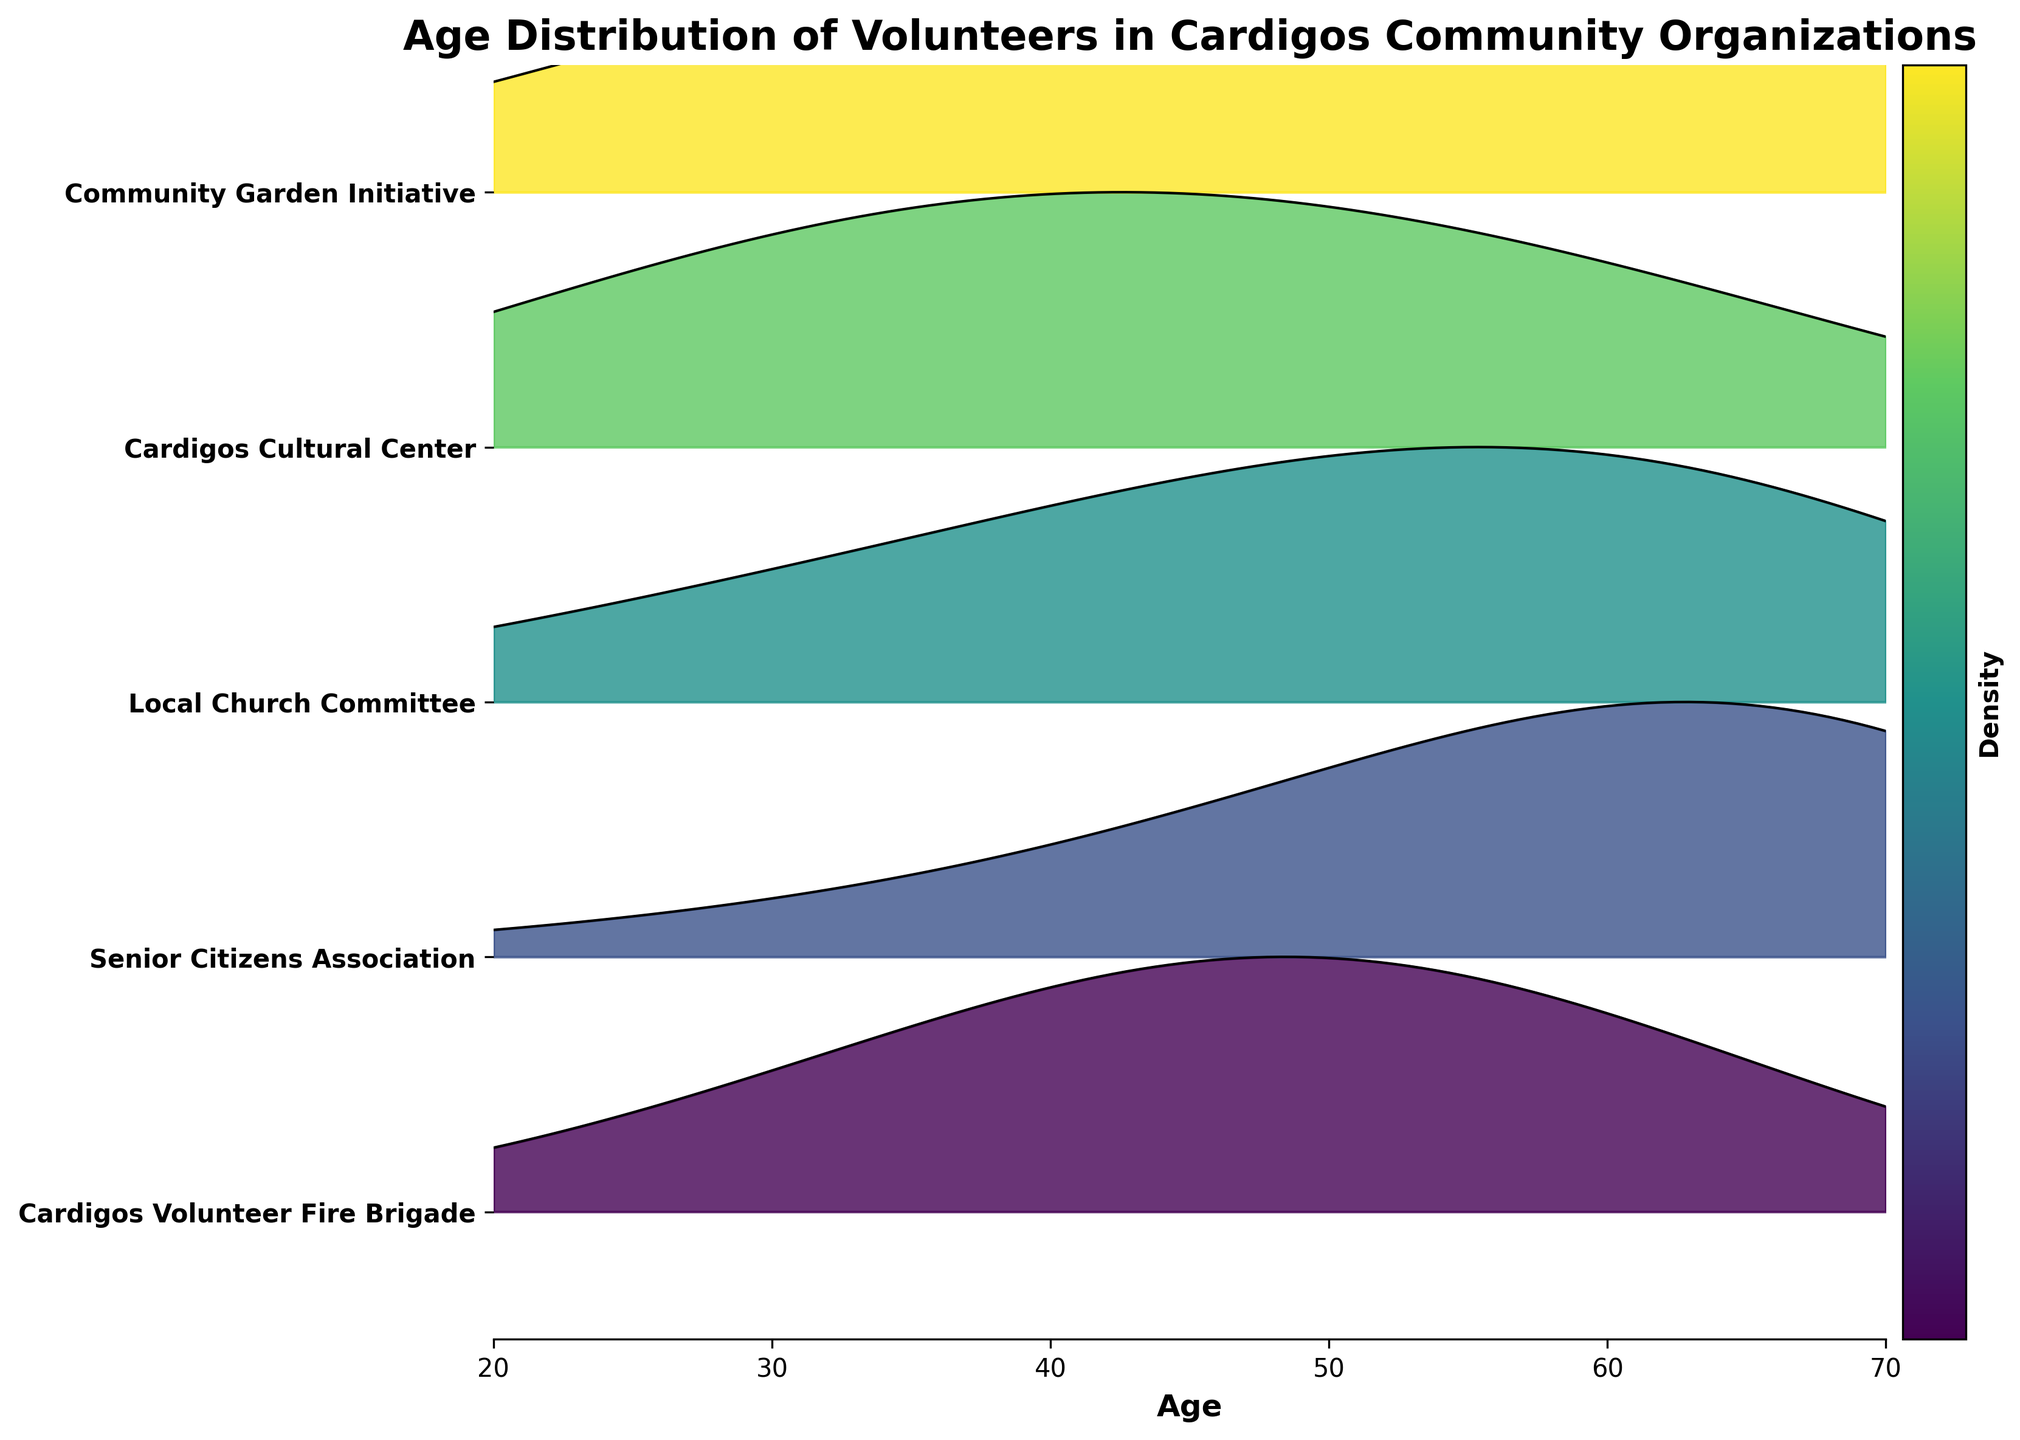What's the title of the plot? The title is located at the top of the plot and clearly states what is being visualized.
Answer: Age Distribution of Volunteers in Cardigos Community Organizations Which organization has the highest density of volunteers aged 70? The height of the ridgelines at age 70 indicates the density. The highest ridge at this age is for the Senior Citizens Association.
Answer: Senior Citizens Association At what age does the Cardigos Volunteer Fire Brigade have the highest density of volunteers? By examining the Cardigos Volunteer Fire Brigade's ridge, the peak density is at age 50.
Answer: 50 Which organization shows the greatest density variation in volunteer ages between 40 and 60? By comparing the ridgelines between ages 40 to 60, the Local Church Committee shows a significant rise in density, peaking at age 60.
Answer: Local Church Committee For the Community Garden Initiative, what is the age where the density sharply decreases? Observing the Community Garden Initiative's ridge, the density sharply decreases after 50.
Answer: 50 Which organization has the youngest age group with the highest density of volunteers? By comparing the peaks at younger ages, the Cardigos Cultural Center peaks at age 20.
Answer: Cardigos Cultural Center How do the densities of the Cardigos Volunteer Fire Brigade and the Community Garden Initiative compare at age 30? The ridgelines at age 30 show similar densities for both organizations, but the Community Garden Initiative has a slightly higher density.
Answer: Community Garden Initiative is higher Which organization has a consistent increase in volunteer density from age 20 to 70? By examining the ridgelines, no organization shows consistent increase throughout; however, the Senior Citizens Association density generally increases, peaking at 70.
Answer: Senior Citizens Association Among the organizations, which has the lowest density peak for any age group? By observing the ridgelines' heights, the Cardigos Volunteer Fire Brigade has the lowest peak density at age 20.
Answer: Cardigos Volunteer Fire Brigade 